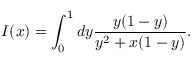<formula> <loc_0><loc_0><loc_500><loc_500>I ( x ) = \int _ { 0 } ^ { 1 } d y { \frac { y ( 1 - y ) } { y ^ { 2 } + x ( 1 - y ) } } .</formula> 